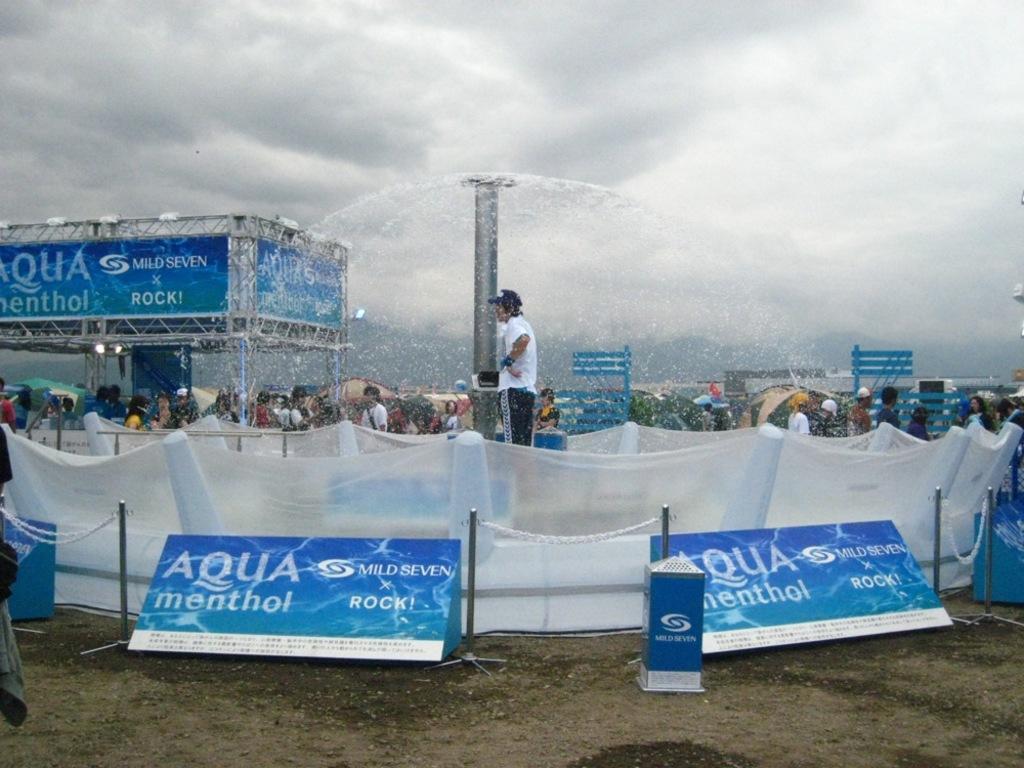Can you describe this image briefly? In the picture we can see a man standing near the pole of the fountain with water and around it we can see a railing with net to it and any advertisement boards with a name Aqua menthol and in the background, we can see some people are standing on the path and we can see some shred and behind it we can see a sky with clouds. 